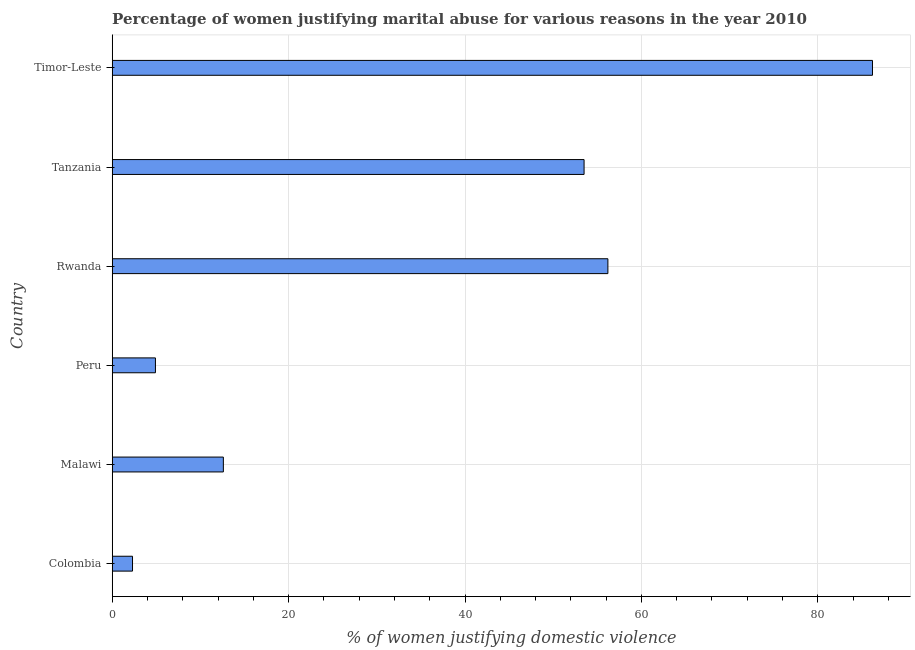What is the title of the graph?
Give a very brief answer. Percentage of women justifying marital abuse for various reasons in the year 2010. What is the label or title of the X-axis?
Keep it short and to the point. % of women justifying domestic violence. What is the percentage of women justifying marital abuse in Peru?
Your answer should be compact. 4.9. Across all countries, what is the maximum percentage of women justifying marital abuse?
Keep it short and to the point. 86.2. In which country was the percentage of women justifying marital abuse maximum?
Your response must be concise. Timor-Leste. What is the sum of the percentage of women justifying marital abuse?
Make the answer very short. 215.7. What is the difference between the percentage of women justifying marital abuse in Malawi and Timor-Leste?
Give a very brief answer. -73.6. What is the average percentage of women justifying marital abuse per country?
Give a very brief answer. 35.95. What is the median percentage of women justifying marital abuse?
Your response must be concise. 33.05. What is the ratio of the percentage of women justifying marital abuse in Peru to that in Rwanda?
Offer a very short reply. 0.09. Is the difference between the percentage of women justifying marital abuse in Colombia and Tanzania greater than the difference between any two countries?
Make the answer very short. No. What is the difference between the highest and the second highest percentage of women justifying marital abuse?
Offer a terse response. 30. What is the difference between the highest and the lowest percentage of women justifying marital abuse?
Your answer should be very brief. 83.9. In how many countries, is the percentage of women justifying marital abuse greater than the average percentage of women justifying marital abuse taken over all countries?
Provide a short and direct response. 3. How many bars are there?
Make the answer very short. 6. How many countries are there in the graph?
Your response must be concise. 6. Are the values on the major ticks of X-axis written in scientific E-notation?
Offer a terse response. No. What is the % of women justifying domestic violence of Rwanda?
Give a very brief answer. 56.2. What is the % of women justifying domestic violence of Tanzania?
Ensure brevity in your answer.  53.5. What is the % of women justifying domestic violence of Timor-Leste?
Keep it short and to the point. 86.2. What is the difference between the % of women justifying domestic violence in Colombia and Malawi?
Your answer should be very brief. -10.3. What is the difference between the % of women justifying domestic violence in Colombia and Rwanda?
Ensure brevity in your answer.  -53.9. What is the difference between the % of women justifying domestic violence in Colombia and Tanzania?
Your response must be concise. -51.2. What is the difference between the % of women justifying domestic violence in Colombia and Timor-Leste?
Your answer should be very brief. -83.9. What is the difference between the % of women justifying domestic violence in Malawi and Peru?
Offer a very short reply. 7.7. What is the difference between the % of women justifying domestic violence in Malawi and Rwanda?
Your answer should be very brief. -43.6. What is the difference between the % of women justifying domestic violence in Malawi and Tanzania?
Provide a succinct answer. -40.9. What is the difference between the % of women justifying domestic violence in Malawi and Timor-Leste?
Give a very brief answer. -73.6. What is the difference between the % of women justifying domestic violence in Peru and Rwanda?
Your answer should be compact. -51.3. What is the difference between the % of women justifying domestic violence in Peru and Tanzania?
Your answer should be very brief. -48.6. What is the difference between the % of women justifying domestic violence in Peru and Timor-Leste?
Provide a succinct answer. -81.3. What is the difference between the % of women justifying domestic violence in Rwanda and Tanzania?
Your response must be concise. 2.7. What is the difference between the % of women justifying domestic violence in Rwanda and Timor-Leste?
Provide a succinct answer. -30. What is the difference between the % of women justifying domestic violence in Tanzania and Timor-Leste?
Your answer should be compact. -32.7. What is the ratio of the % of women justifying domestic violence in Colombia to that in Malawi?
Your response must be concise. 0.18. What is the ratio of the % of women justifying domestic violence in Colombia to that in Peru?
Provide a short and direct response. 0.47. What is the ratio of the % of women justifying domestic violence in Colombia to that in Rwanda?
Make the answer very short. 0.04. What is the ratio of the % of women justifying domestic violence in Colombia to that in Tanzania?
Your answer should be compact. 0.04. What is the ratio of the % of women justifying domestic violence in Colombia to that in Timor-Leste?
Keep it short and to the point. 0.03. What is the ratio of the % of women justifying domestic violence in Malawi to that in Peru?
Provide a short and direct response. 2.57. What is the ratio of the % of women justifying domestic violence in Malawi to that in Rwanda?
Provide a short and direct response. 0.22. What is the ratio of the % of women justifying domestic violence in Malawi to that in Tanzania?
Give a very brief answer. 0.24. What is the ratio of the % of women justifying domestic violence in Malawi to that in Timor-Leste?
Ensure brevity in your answer.  0.15. What is the ratio of the % of women justifying domestic violence in Peru to that in Rwanda?
Offer a very short reply. 0.09. What is the ratio of the % of women justifying domestic violence in Peru to that in Tanzania?
Make the answer very short. 0.09. What is the ratio of the % of women justifying domestic violence in Peru to that in Timor-Leste?
Provide a succinct answer. 0.06. What is the ratio of the % of women justifying domestic violence in Rwanda to that in Tanzania?
Ensure brevity in your answer.  1.05. What is the ratio of the % of women justifying domestic violence in Rwanda to that in Timor-Leste?
Provide a succinct answer. 0.65. What is the ratio of the % of women justifying domestic violence in Tanzania to that in Timor-Leste?
Offer a terse response. 0.62. 